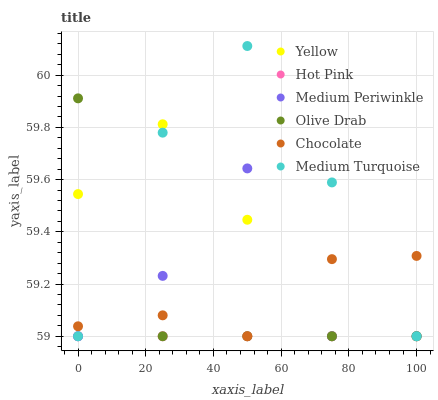Does Hot Pink have the minimum area under the curve?
Answer yes or no. Yes. Does Medium Turquoise have the maximum area under the curve?
Answer yes or no. Yes. Does Medium Periwinkle have the minimum area under the curve?
Answer yes or no. No. Does Medium Periwinkle have the maximum area under the curve?
Answer yes or no. No. Is Hot Pink the smoothest?
Answer yes or no. Yes. Is Medium Periwinkle the roughest?
Answer yes or no. Yes. Is Yellow the smoothest?
Answer yes or no. No. Is Yellow the roughest?
Answer yes or no. No. Does Hot Pink have the lowest value?
Answer yes or no. Yes. Does Medium Turquoise have the highest value?
Answer yes or no. Yes. Does Medium Periwinkle have the highest value?
Answer yes or no. No. Does Medium Turquoise intersect Chocolate?
Answer yes or no. Yes. Is Medium Turquoise less than Chocolate?
Answer yes or no. No. Is Medium Turquoise greater than Chocolate?
Answer yes or no. No. 